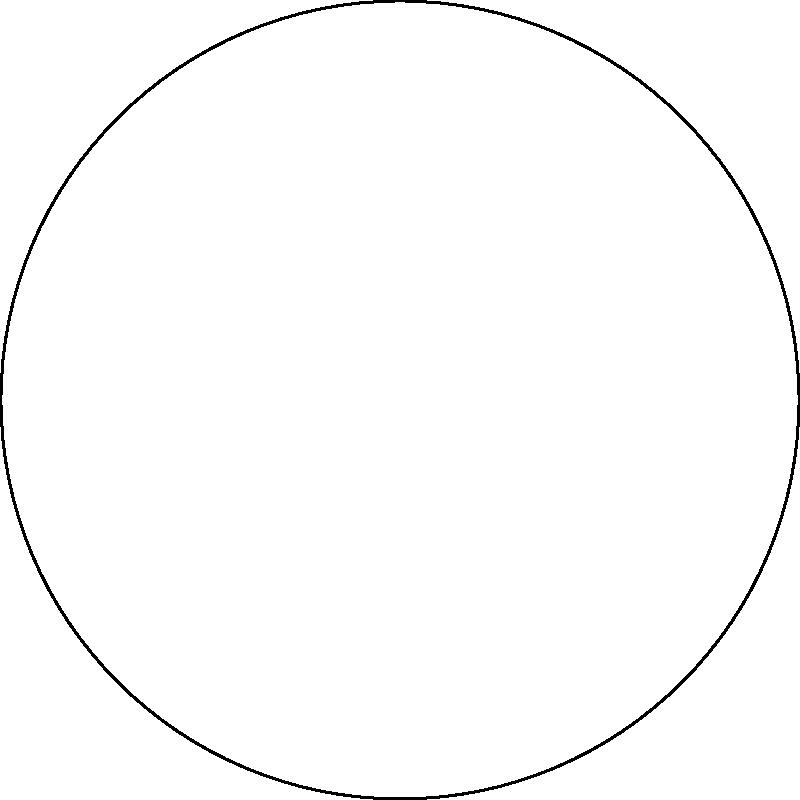In the Poincaré disk model of hyperbolic geometry shown above, three points A, B, and C are connected by geodesics (represented by blue, red, and green arcs). Which statement about the sum of the interior angles of triangle ABC is correct in this hyperbolic space? To understand this concept, let's break it down step-by-step:

1. In Euclidean geometry, the sum of interior angles of a triangle is always 180°.

2. However, in hyperbolic geometry, this rule doesn't apply. The Poincaré disk model is a way to represent hyperbolic geometry in a Euclidean plane.

3. In the Poincaré disk model:
   - The disk represents the entire hyperbolic plane.
   - Straight lines in hyperbolic space are represented by arcs of circles that are perpendicular to the boundary of the disk.

4. A key property of hyperbolic geometry is that the sum of the interior angles of a triangle is always less than 180°.

5. The larger the triangle appears in the Poincaré disk model, the smaller the sum of its interior angles will be.

6. In the given diagram, we can see that the triangle ABC occupies a significant portion of the disk, suggesting that its angles in hyperbolic space are relatively small.

7. Therefore, we can conclude that the sum of the interior angles of triangle ABC in this hyperbolic space is less than 180°.

This concept is crucial in understanding the differences between Euclidean and non-Euclidean geometries, which is particularly relevant for animators dealing with special effects or creating fantastical worlds inspired by works like those of Ray Harryhausen.
Answer: Less than 180° 